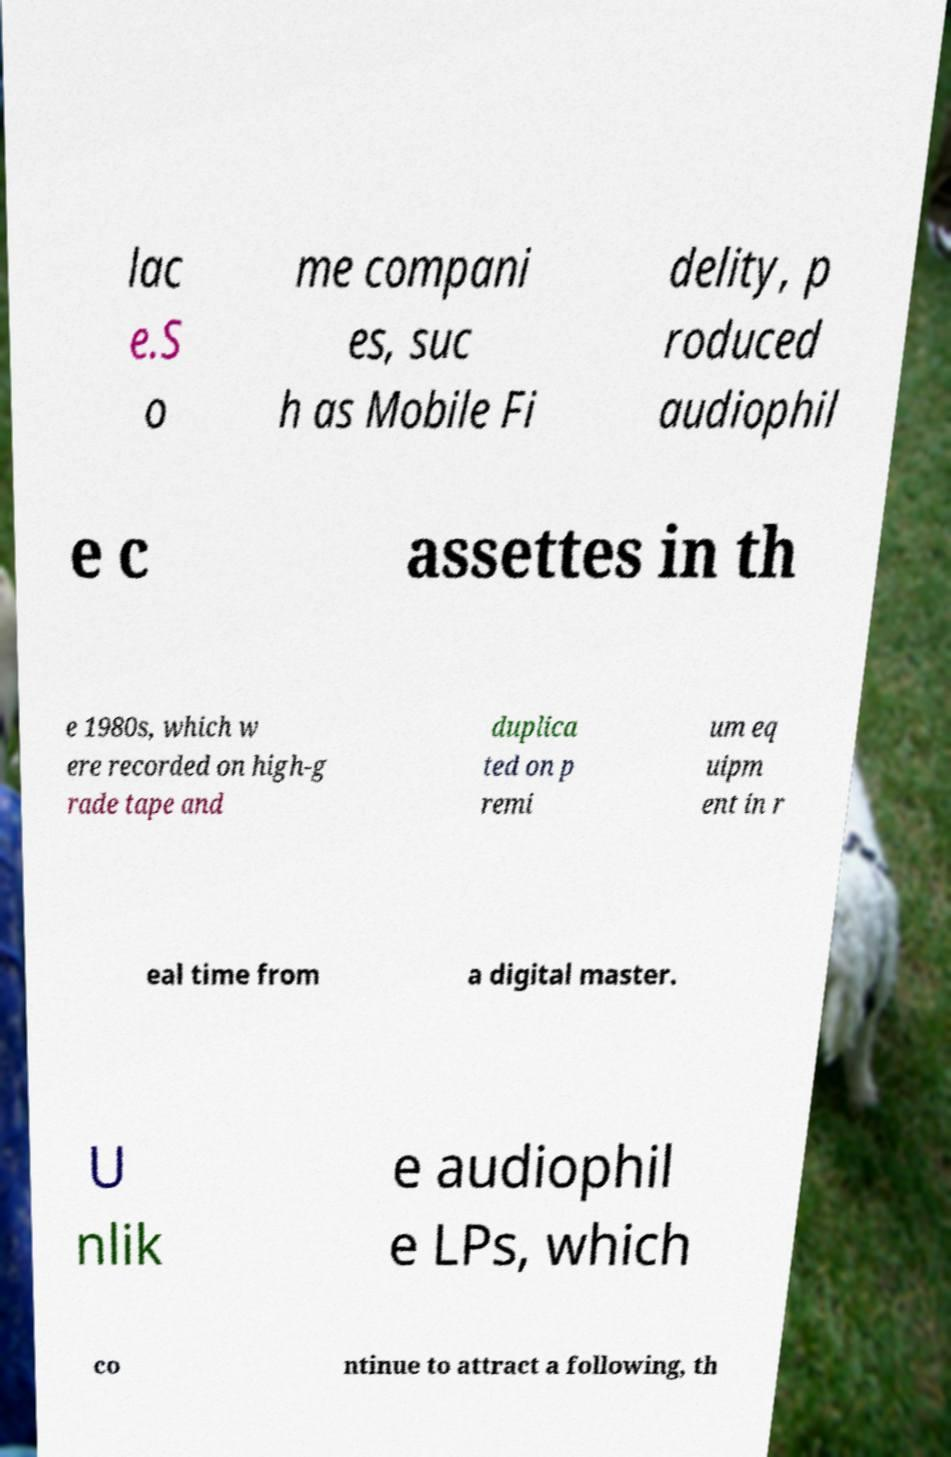Can you read and provide the text displayed in the image?This photo seems to have some interesting text. Can you extract and type it out for me? lac e.S o me compani es, suc h as Mobile Fi delity, p roduced audiophil e c assettes in th e 1980s, which w ere recorded on high-g rade tape and duplica ted on p remi um eq uipm ent in r eal time from a digital master. U nlik e audiophil e LPs, which co ntinue to attract a following, th 